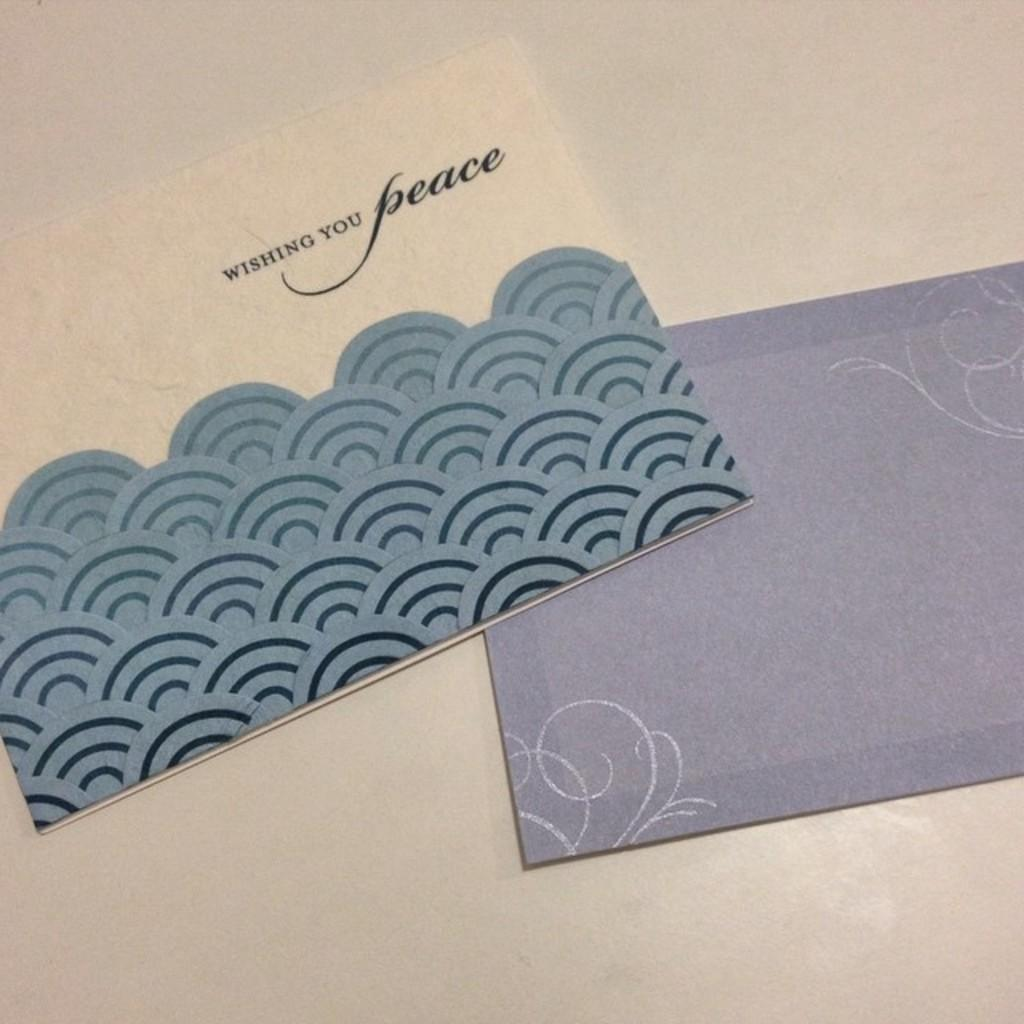<image>
Present a compact description of the photo's key features. Wishing you peace card with envelope for it 